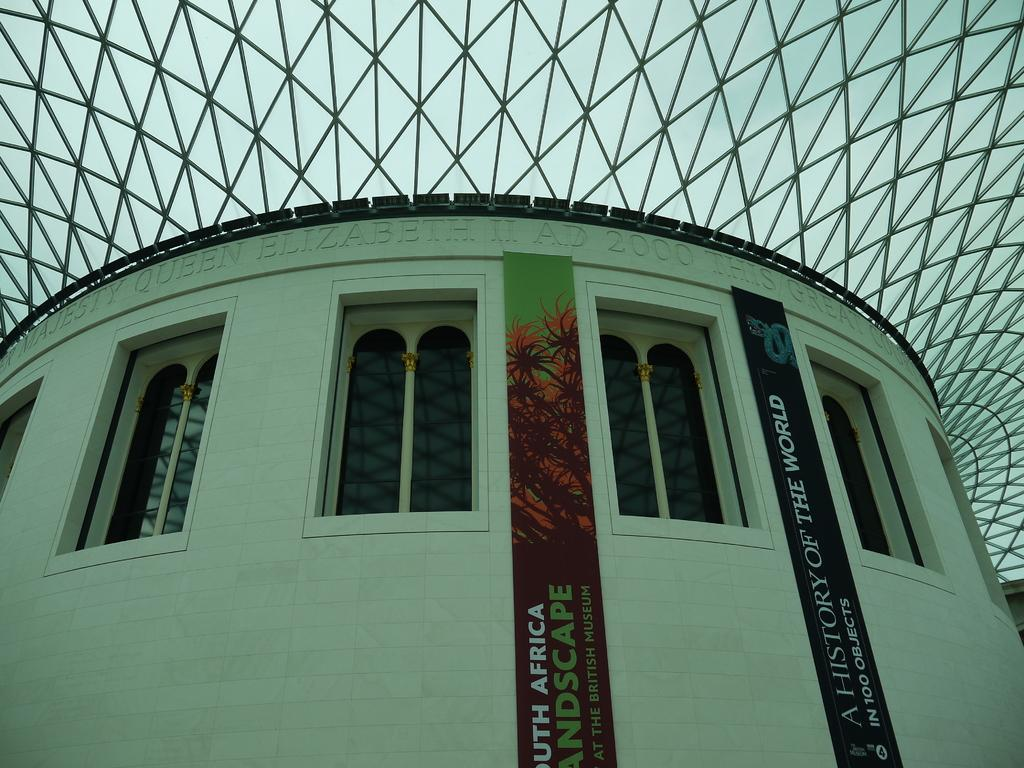What type of structure is visible in the image? There is a building in the image. What feature can be seen on the building? The building has windows. Are there any decorations or signs on the building? Yes, there are banners on the building. Is there any text visible on the building? Yes, there is writing on the building. Where is the baby playing with dirt in the image? There is no baby or dirt present in the image; it only features a building with windows, banners, and writing. 